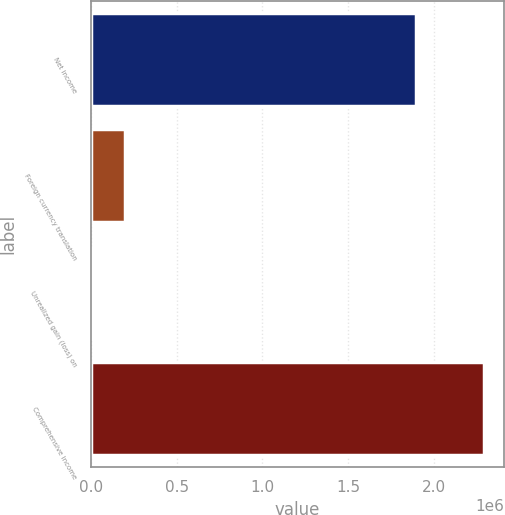Convert chart. <chart><loc_0><loc_0><loc_500><loc_500><bar_chart><fcel>Net income<fcel>Foreign currency translation<fcel>Unrealized gain (loss) on<fcel>Comprehensive income<nl><fcel>1.8928e+06<fcel>200126<fcel>21<fcel>2.29301e+06<nl></chart> 